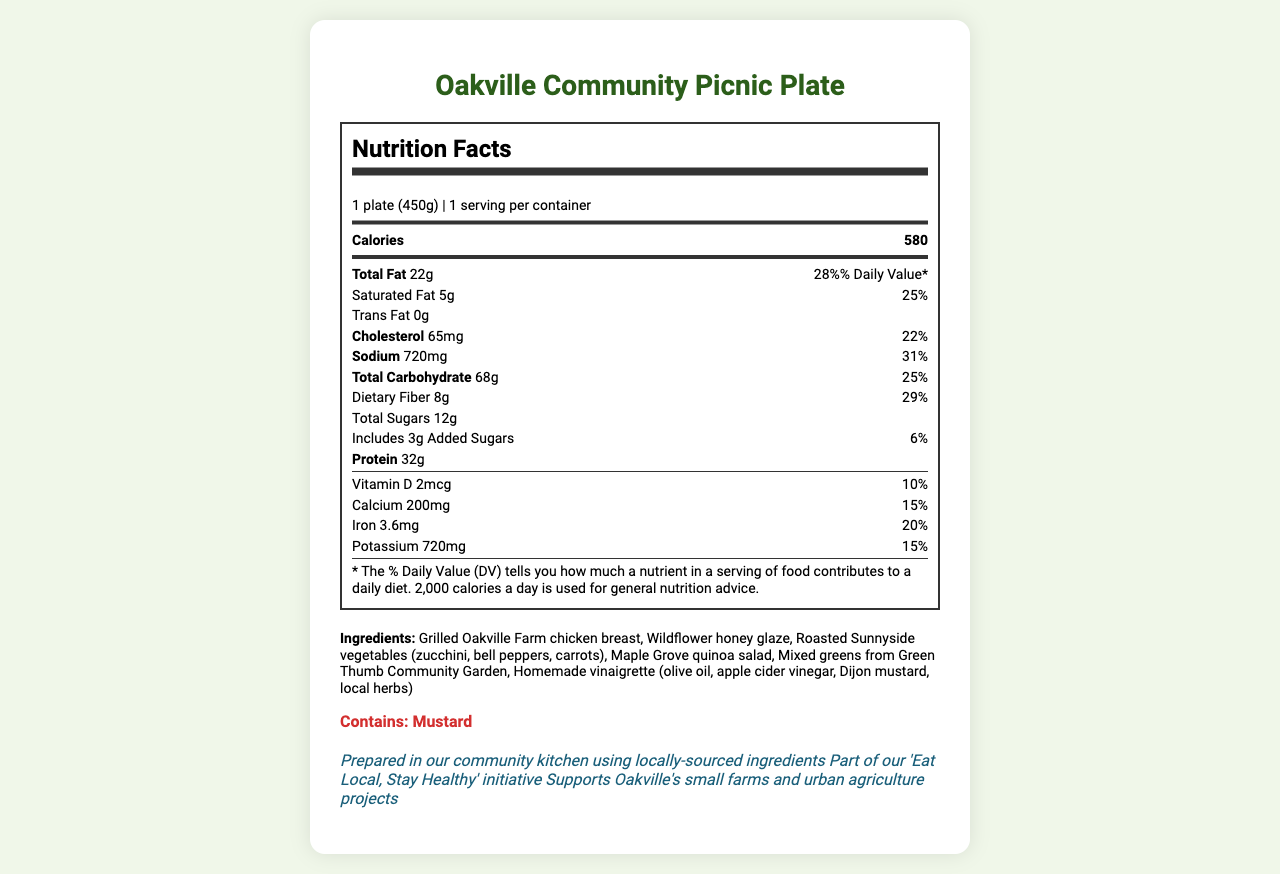what is the product name? The product name is displayed at the top of the document.
Answer: Oakville Community Picnic Plate what is the serving size of the meal? The serving size is mentioned under the Nutrition Facts heading.
Answer: 1 plate (450g) how many calories are in one serving? The number of calories is listed next to "Calories" under the Nutrition Facts section.
Answer: 580 what is the total amount of fat in grams? The total amount of fat is shown as 22g in the Nutrition Facts section.
Answer: 22g how much of the daily value of dietary fiber does this meal provide? The daily value percentage of dietary fiber is listed as 29% in the Nutrition Facts.
Answer: 29% what ingredient is NOT found in the Oakville Community Picnic Plate? A. Grilled Oakville Farm chicken breast B. Wildflower honey glaze C. Almonds D. Roasted Sunnyside vegetables Almonds are not mentioned in the list of ingredients.
Answer: C. Almonds which nutrient has the highest daily value percentage? A. Sodium B. Total Fat C. Calcium D. Dietary Fiber Sodium has the highest daily value percentage at 31%.
Answer: A. Sodium does this meal contain any cholesterol? The document states that the meal contains 65mg of cholesterol.
Answer: Yes summarize the main idea of the document. The document gives an overview of the nutritional content, ingredients, and community-focused aspects of the Oakville Community Picnic Plate.
Answer: The document provides the Nutrition Facts, ingredient list, allergen information, and additional details for the Oakville Community Picnic Plate. It describes a meal prepared with locally-sourced ingredients, listing nutritional values per serving, and supporting Oakville's small farms and urban agriculture projects. is the Oakville Community Picnic Plate suitable for someone with a mustard allergy? The allergen information states that the meal contains mustard.
Answer: No how many grams of total carbohydrates are in this meal? The total carbohydrates are shown as 68g in the Nutrition Facts.
Answer: 68g what initiative is mentioned in relation to this meal? The additional information mentions the 'Eat Local, Stay Healthy' initiative as part of the meal's context.
Answer: 'Eat Local, Stay Healthy' who provides the mixed greens for the Oakville Community Picnic Plate? The ingredients list specifies that the mixed greens are sourced from the Green Thumb Community Garden.
Answer: Green Thumb Community Garden what is the amount of potassium in the meal? The Nutrition Facts list the potassium amount as 720mg.
Answer: 720mg what is the email address to contact for more information about the meal? The document does not provide an email address or contact information; hence, it cannot be determined visually.
Answer: Not enough information what percentage of daily value does the protein content meet? The document lists the amount of protein as 32g but does not provide a daily value percentage for it.
Answer: Not Specified 